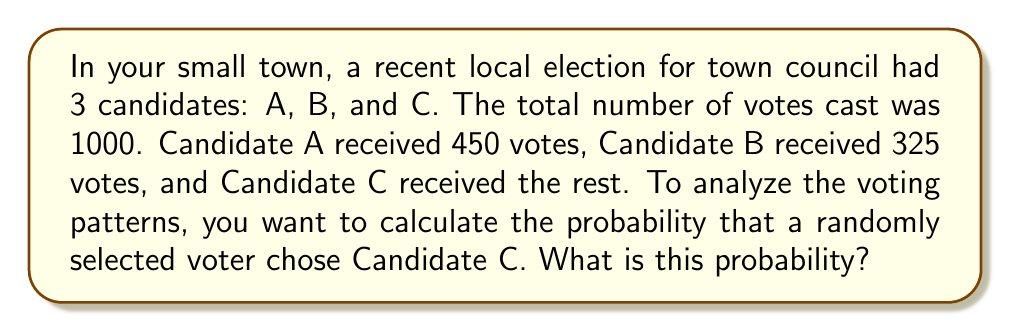Can you solve this math problem? To solve this problem, we'll follow these steps:

1. Determine the number of votes Candidate C received:
   Total votes = 1000
   Votes for A = 450
   Votes for B = 325
   Votes for C = Total votes - (Votes for A + Votes for B)
   Votes for C = 1000 - (450 + 325) = 1000 - 775 = 225

2. Calculate the probability of selecting a voter who chose Candidate C:
   Probability = (Number of favorable outcomes) / (Total number of possible outcomes)
   
   In this case:
   Favorable outcomes = Votes for C = 225
   Total possible outcomes = Total votes = 1000

   Probability = 225 / 1000 = 0.225

3. Express the probability as a percentage:
   0.225 * 100 = 22.5%

Therefore, the probability that a randomly selected voter chose Candidate C is 0.225 or 22.5%.
Answer: 0.225 